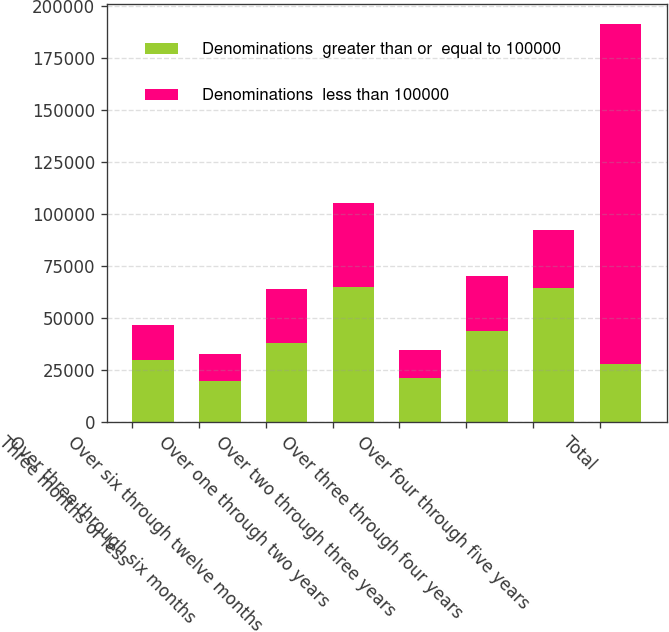Convert chart. <chart><loc_0><loc_0><loc_500><loc_500><stacked_bar_chart><ecel><fcel>Three months or less<fcel>Over three through six months<fcel>Over six through twelve months<fcel>Over one through two years<fcel>Over two through three years<fcel>Over three through four years<fcel>Over four through five years<fcel>Total<nl><fcel>Denominations  greater than or  equal to 100000<fcel>29611<fcel>19714<fcel>37911<fcel>65051<fcel>21200<fcel>43654<fcel>64552<fcel>27812<nl><fcel>Denominations  less than 100000<fcel>16960<fcel>12716<fcel>26078<fcel>40434<fcel>13504<fcel>26245<fcel>27812<fcel>163749<nl></chart> 